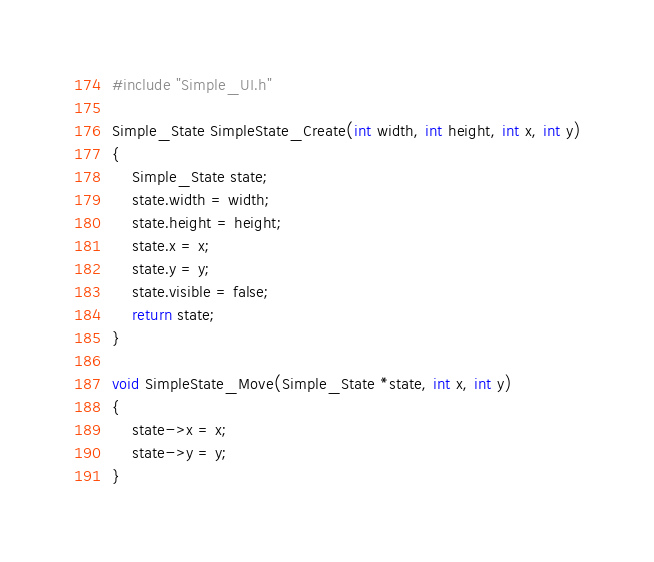<code> <loc_0><loc_0><loc_500><loc_500><_C++_>#include "Simple_UI.h"

Simple_State SimpleState_Create(int width, int height, int x, int y)
{
	Simple_State state;
	state.width = width;
	state.height = height;
	state.x = x;
	state.y = y;
	state.visible = false;
	return state;
}

void SimpleState_Move(Simple_State *state, int x, int y)
{
	state->x = x;
	state->y = y;
}</code> 